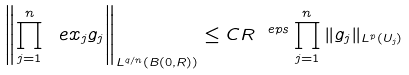Convert formula to latex. <formula><loc_0><loc_0><loc_500><loc_500>\left \| \prod _ { j = 1 } ^ { n } \ e x _ { j } g _ { j } \right \| _ { L ^ { q / n } ( B ( 0 , R ) ) } \leq C R ^ { \ e p s } \prod _ { j = 1 } ^ { n } \| g _ { j } \| _ { L ^ { p } ( U _ { j } ) }</formula> 